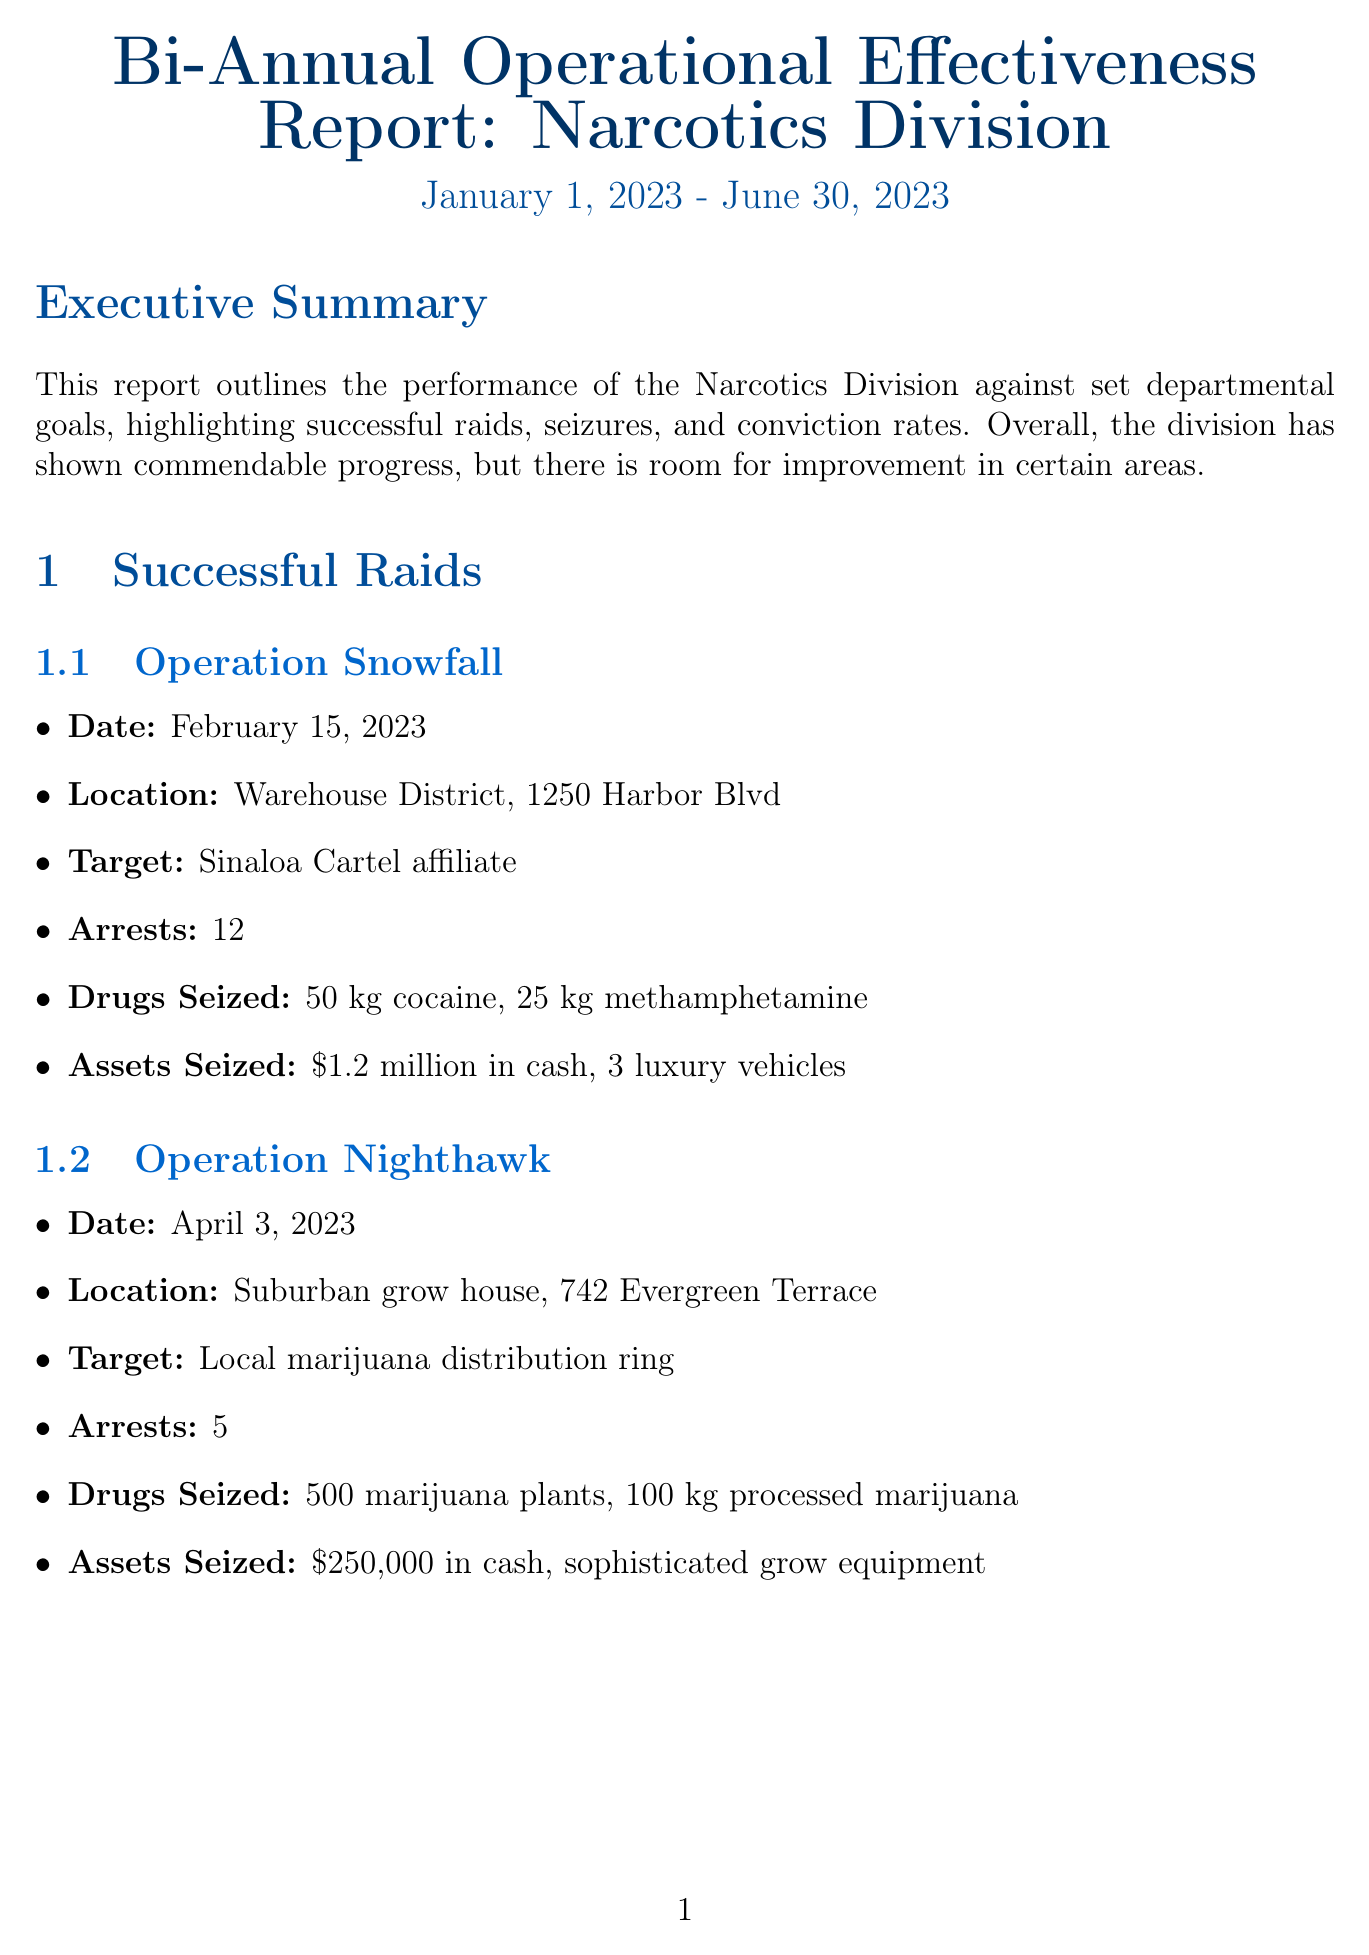what is the time period of the report? The report covers the performance from January 1, 2023 to June 30, 2023.
Answer: January 1, 2023 - June 30, 2023 how many successful raids were conducted? The report outlines three successful raids conducted by the Narcotics Division.
Answer: 3 what is the estimated street value of the cocaine seized on March 10, 2023? The document states the estimated street value of the cocaine seized was $25 million when it was intercepted.
Answer: $25 million who led Operation Nighthawk? The report does not specify a detective for Operation Nighthawk, but it lists the details of the operation.
Answer: Not specified what was the conviction rate achieved by the division? The conviction rate reported was 89.4 percent, providing a measure of successful convictions to total arrests.
Answer: 89.4% how many narcotics valued at, in total, were seized against the departmental goal? The goal was to seize narcotics valued at $50 million, and the actual value seized was $42.5 million.
Answer: $42.5 million who is commended for leading Operation Snowfall? The report highlights Sarah Johnson for her leadership in Operation Snowfall, which was significant for cocaine seizure.
Answer: Sarah Johnson what areas are identified for improvement in the report? The document lists several areas for improvement, including intelligence gathering and better coordination with federal agencies.
Answer: Enhance intelligence gathering, coordination with federal agencies, focus on prescription drug diversion cases, advanced training for undercover operations 